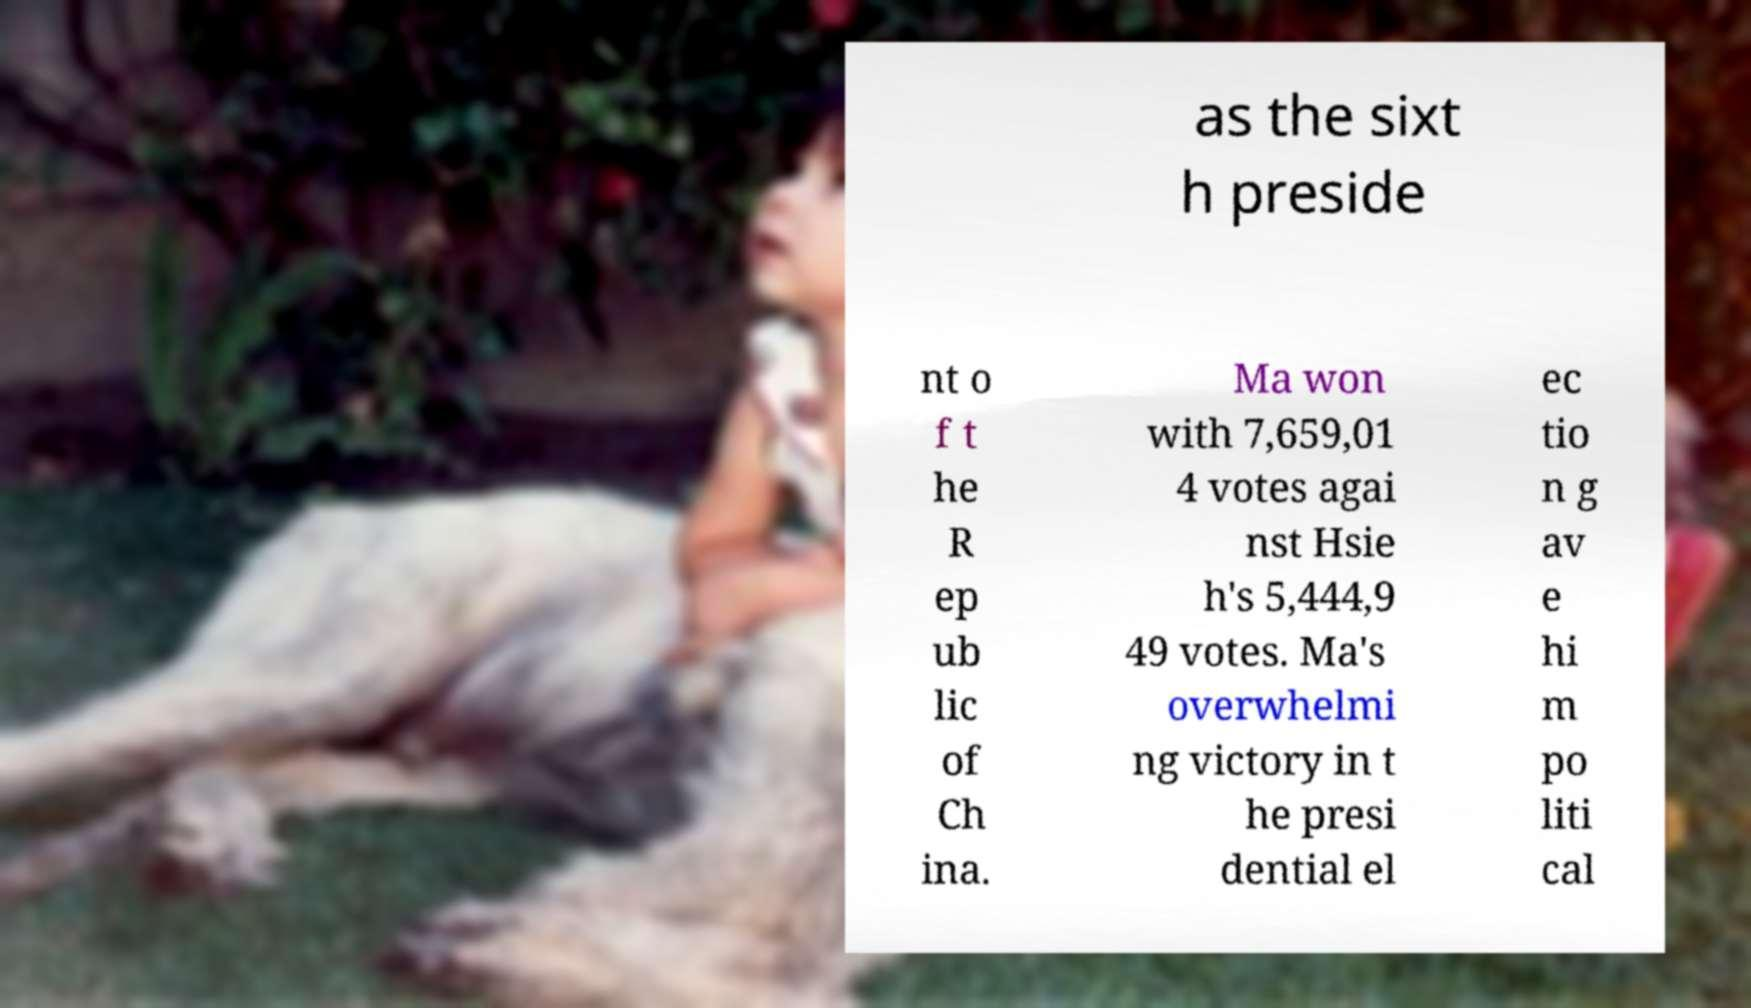For documentation purposes, I need the text within this image transcribed. Could you provide that? as the sixt h preside nt o f t he R ep ub lic of Ch ina. Ma won with 7,659,01 4 votes agai nst Hsie h's 5,444,9 49 votes. Ma's overwhelmi ng victory in t he presi dential el ec tio n g av e hi m po liti cal 